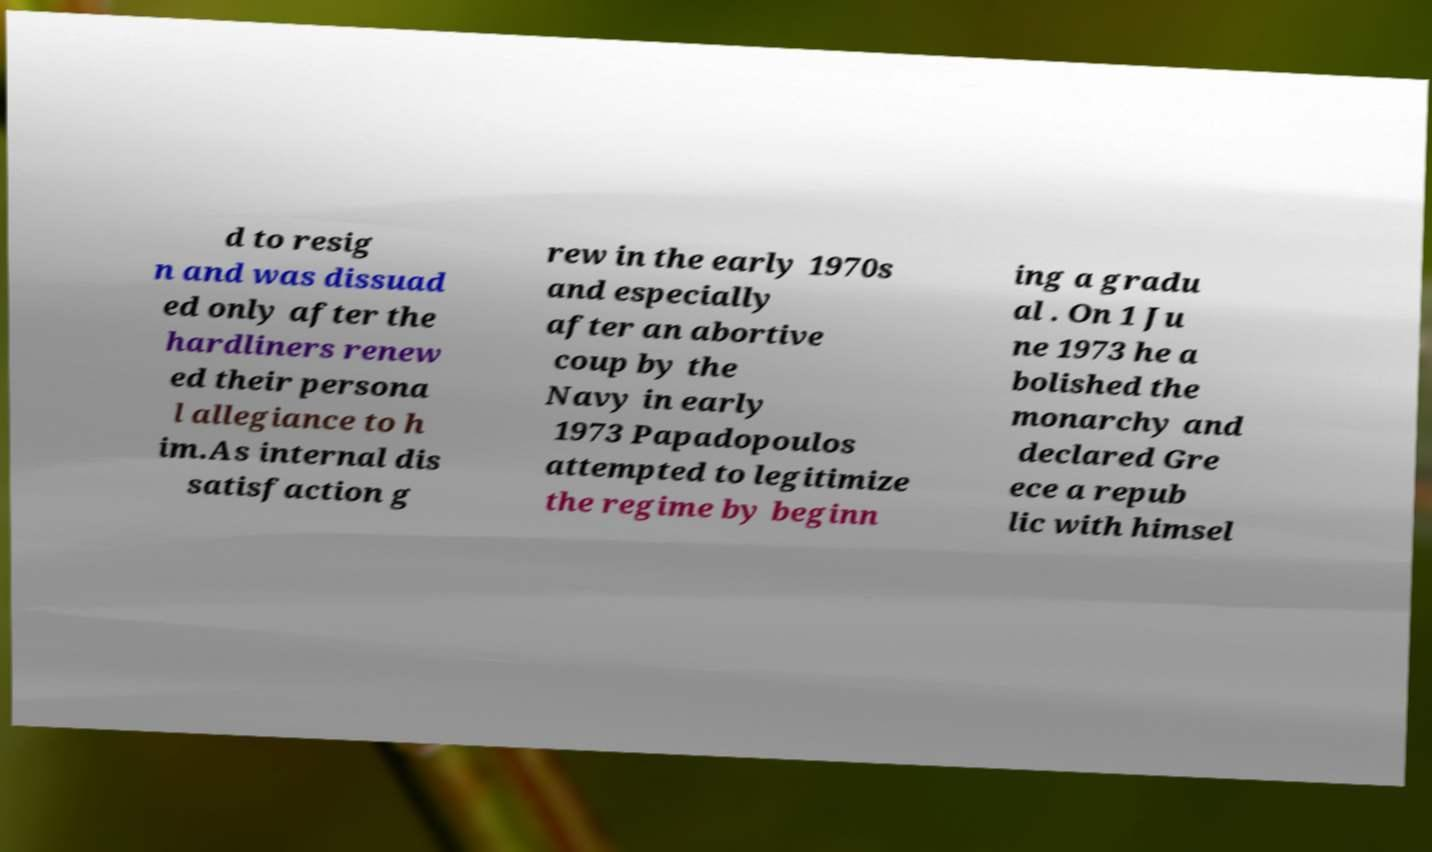Please identify and transcribe the text found in this image. d to resig n and was dissuad ed only after the hardliners renew ed their persona l allegiance to h im.As internal dis satisfaction g rew in the early 1970s and especially after an abortive coup by the Navy in early 1973 Papadopoulos attempted to legitimize the regime by beginn ing a gradu al . On 1 Ju ne 1973 he a bolished the monarchy and declared Gre ece a repub lic with himsel 